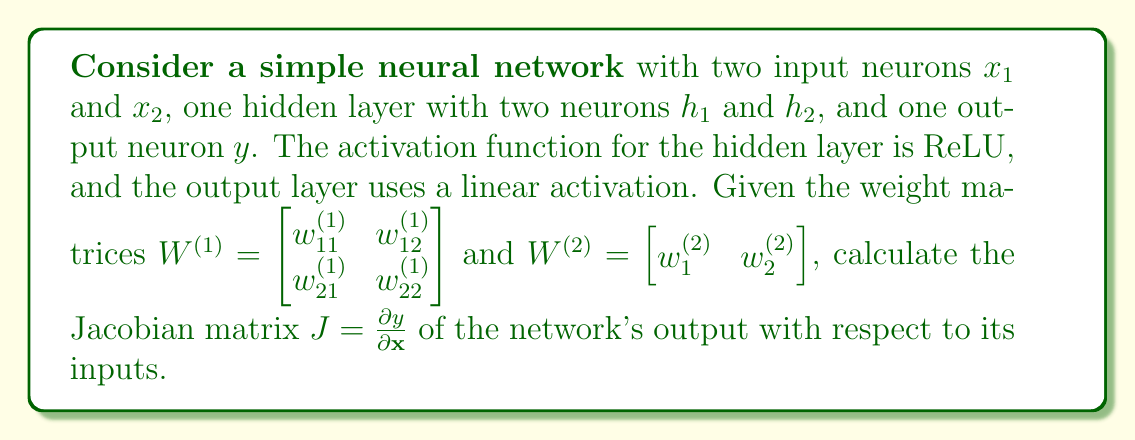Provide a solution to this math problem. To calculate the Jacobian matrix, we need to follow these steps:

1) First, let's write out the equations for the neural network:

   $$h_1 = \text{ReLU}(w_{11}^{(1)}x_1 + w_{21}^{(1)}x_2)$$
   $$h_2 = \text{ReLU}(w_{12}^{(1)}x_1 + w_{22}^{(1)}x_2)$$
   $$y = w_{1}^{(2)}h_1 + w_{2}^{(2)}h_2$$

2) The Jacobian matrix will be a 1x2 matrix (row vector) since we have one output and two inputs:

   $$J = \begin{bmatrix} \frac{\partial y}{\partial x_1} & \frac{\partial y}{\partial x_2} \end{bmatrix}$$

3) We need to calculate each partial derivative using the chain rule:

   $$\frac{\partial y}{\partial x_1} = \frac{\partial y}{\partial h_1}\frac{\partial h_1}{\partial x_1} + \frac{\partial y}{\partial h_2}\frac{\partial h_2}{\partial x_1}$$
   $$\frac{\partial y}{\partial x_2} = \frac{\partial y}{\partial h_1}\frac{\partial h_1}{\partial x_2} + \frac{\partial y}{\partial h_2}\frac{\partial h_2}{\partial x_2}$$

4) Let's calculate each term:

   $\frac{\partial y}{\partial h_1} = w_{1}^{(2)}$
   $\frac{\partial y}{\partial h_2} = w_{2}^{(2)}$

   $\frac{\partial h_1}{\partial x_1} = w_{11}^{(1)} \cdot \mathbb{1}_{w_{11}^{(1)}x_1 + w_{21}^{(1)}x_2 > 0}$
   $\frac{\partial h_1}{\partial x_2} = w_{21}^{(1)} \cdot \mathbb{1}_{w_{11}^{(1)}x_1 + w_{21}^{(1)}x_2 > 0}$

   $\frac{\partial h_2}{\partial x_1} = w_{12}^{(1)} \cdot \mathbb{1}_{w_{12}^{(1)}x_1 + w_{22}^{(1)}x_2 > 0}$
   $\frac{\partial h_2}{\partial x_2} = w_{22}^{(1)} \cdot \mathbb{1}_{w_{12}^{(1)}x_1 + w_{22}^{(1)}x_2 > 0}$

   Here, $\mathbb{1}_{condition}$ is the indicator function, which is 1 when the condition is true and 0 otherwise.

5) Substituting these back into our Jacobian:

   $$J = \begin{bmatrix} 
   w_{1}^{(2)}w_{11}^{(1)}\mathbb{1}_{w_{11}^{(1)}x_1 + w_{21}^{(1)}x_2 > 0} + w_{2}^{(2)}w_{12}^{(1)}\mathbb{1}_{w_{12}^{(1)}x_1 + w_{22}^{(1)}x_2 > 0} & 
   w_{1}^{(2)}w_{21}^{(1)}\mathbb{1}_{w_{11}^{(1)}x_1 + w_{21}^{(1)}x_2 > 0} + w_{2}^{(2)}w_{22}^{(1)}\mathbb{1}_{w_{12}^{(1)}x_1 + w_{22}^{(1)}x_2 > 0}
   \end{bmatrix}$$

This is the Jacobian matrix of the network's output with respect to its inputs.
Answer: $$J = \begin{bmatrix} 
w_{1}^{(2)}w_{11}^{(1)}\mathbb{1}_{w_{11}^{(1)}x_1 + w_{21}^{(1)}x_2 > 0} + w_{2}^{(2)}w_{12}^{(1)}\mathbb{1}_{w_{12}^{(1)}x_1 + w_{22}^{(1)}x_2 > 0} & 
w_{1}^{(2)}w_{21}^{(1)}\mathbb{1}_{w_{11}^{(1)}x_1 + w_{21}^{(1)}x_2 > 0} + w_{2}^{(2)}w_{22}^{(1)}\mathbb{1}_{w_{12}^{(1)}x_1 + w_{22}^{(1)}x_2 > 0}
\end{bmatrix}$$ 